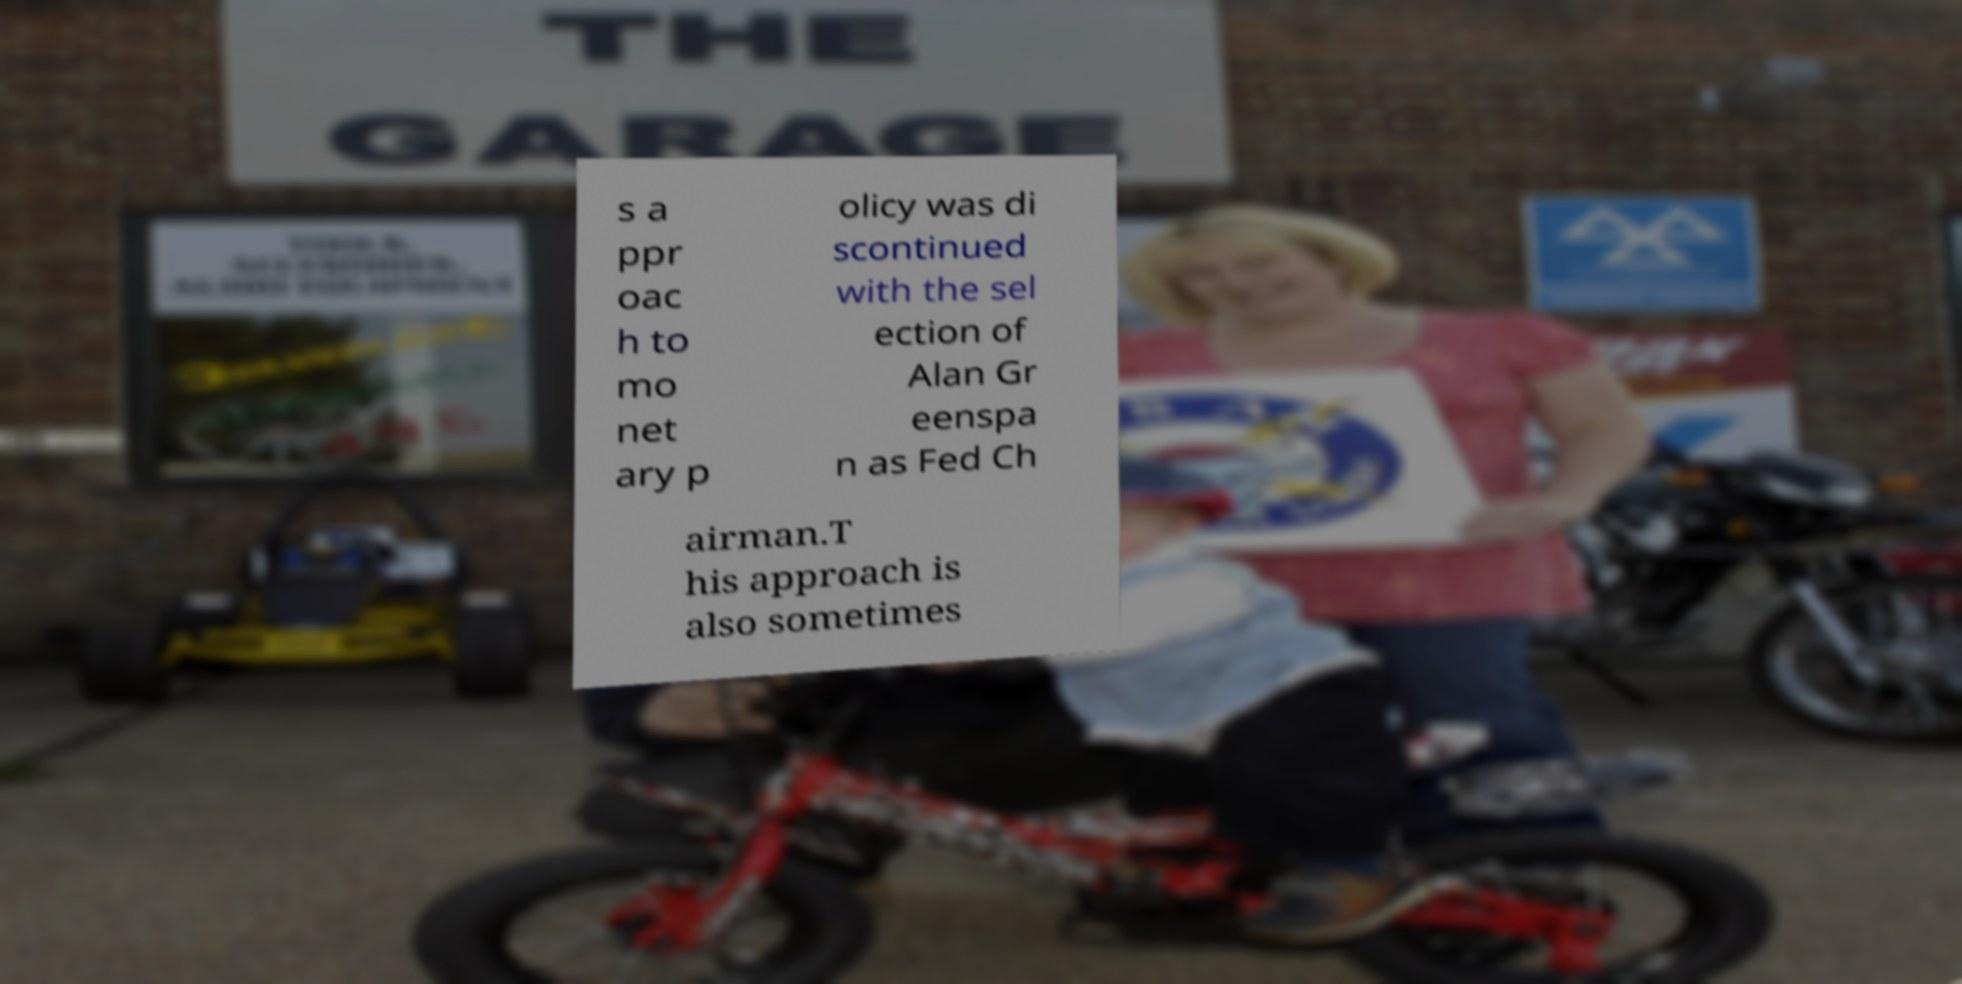I need the written content from this picture converted into text. Can you do that? s a ppr oac h to mo net ary p olicy was di scontinued with the sel ection of Alan Gr eenspa n as Fed Ch airman.T his approach is also sometimes 